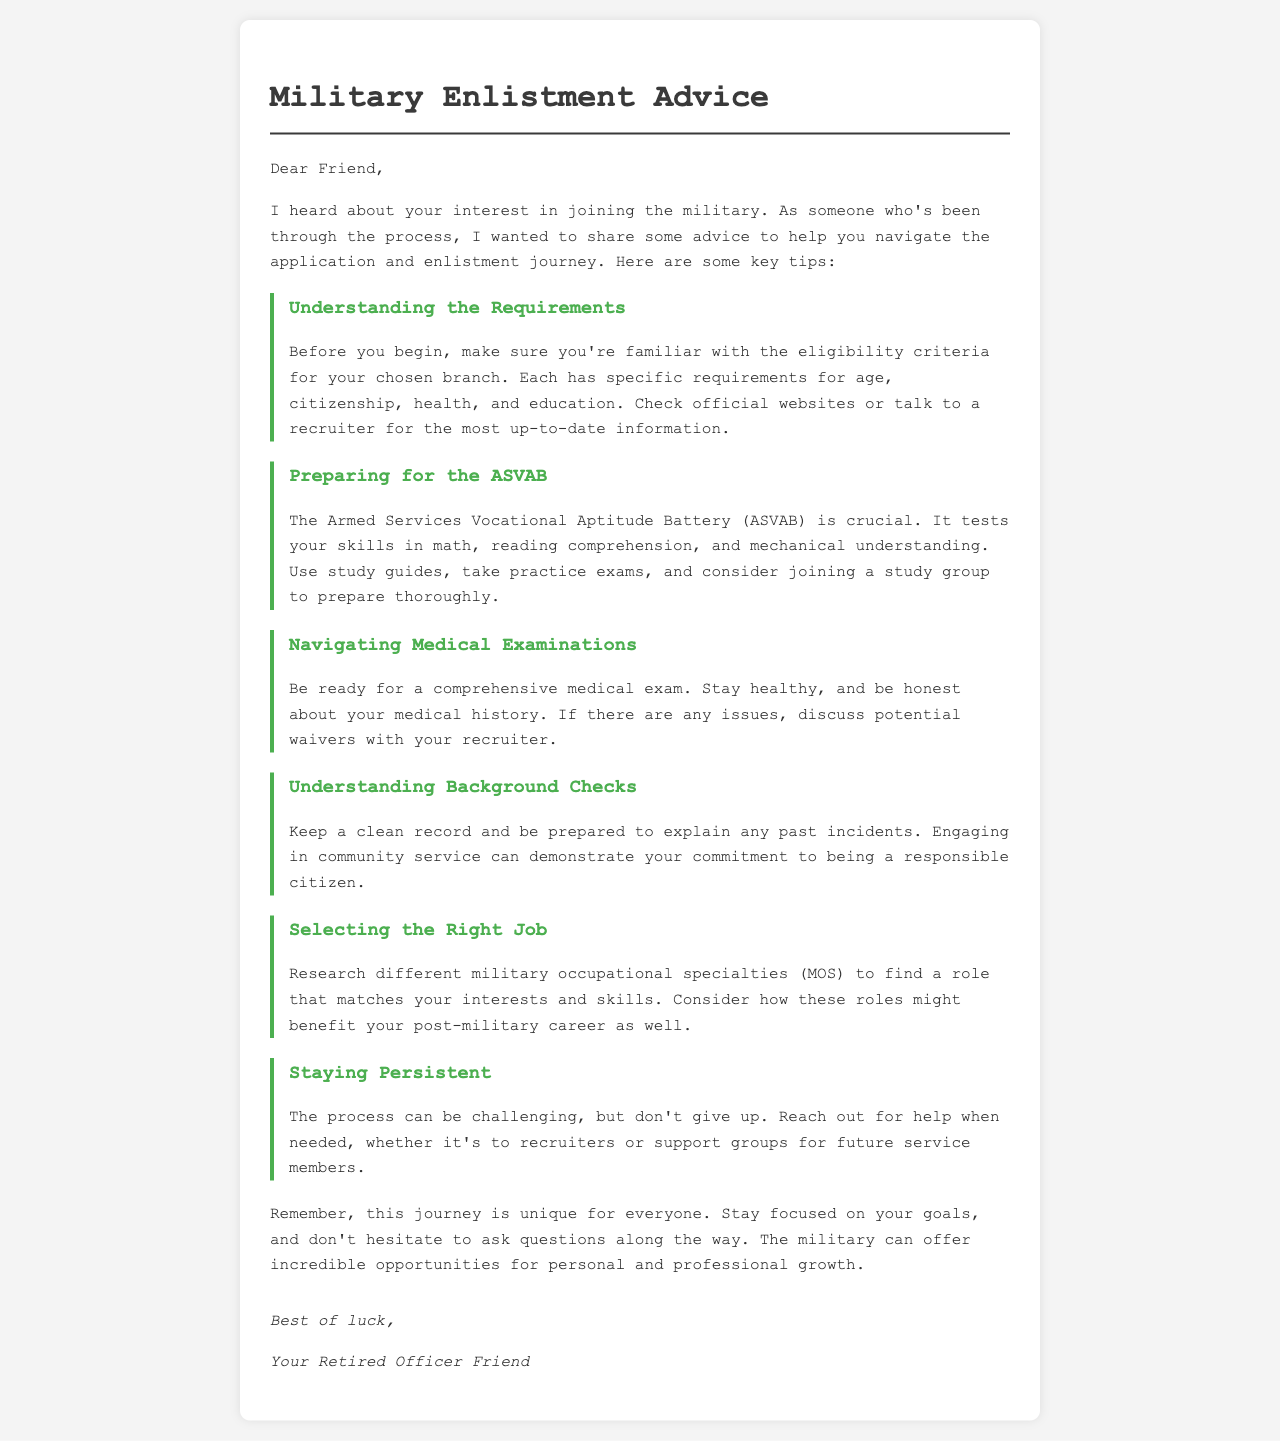what is the title of the document? The title of the document is located in the header section, which indicates the main subject of the correspondence.
Answer: Military Enlistment Advice who is the letter addressed to? The letter begins with a direct greeting, indicating who the intended reader is.
Answer: Friend what is the first tip regarding enlistment? The first tip listed provides essential information about entering the military, specifically focusing on qualifications.
Answer: Understanding the Requirements what is the acronym for the military aptitude test mentioned? The document references a specific test used in military enlistment, which is critical for evaluating candidates.
Answer: ASVAB what should you prepare for in relation to the ASVAB? The document outlines important preparations related to a specific assessment crucial for enlistment.
Answer: study guides, practice exams what is suggested to maintain before the medical examination? The document advises certain behaviors that contribute positively to the medical examination process.
Answer: Stay healthy how can you demonstrate your responsibility during background checks? The letter mentions activities that could reflect positively on a candidate’s character during an evaluation process.
Answer: community service what is the overall tone of the advice provided in the letter? The letter conveys the author's perspective on the experience of joining the military, indicating an encouraging attitude.
Answer: supportive 